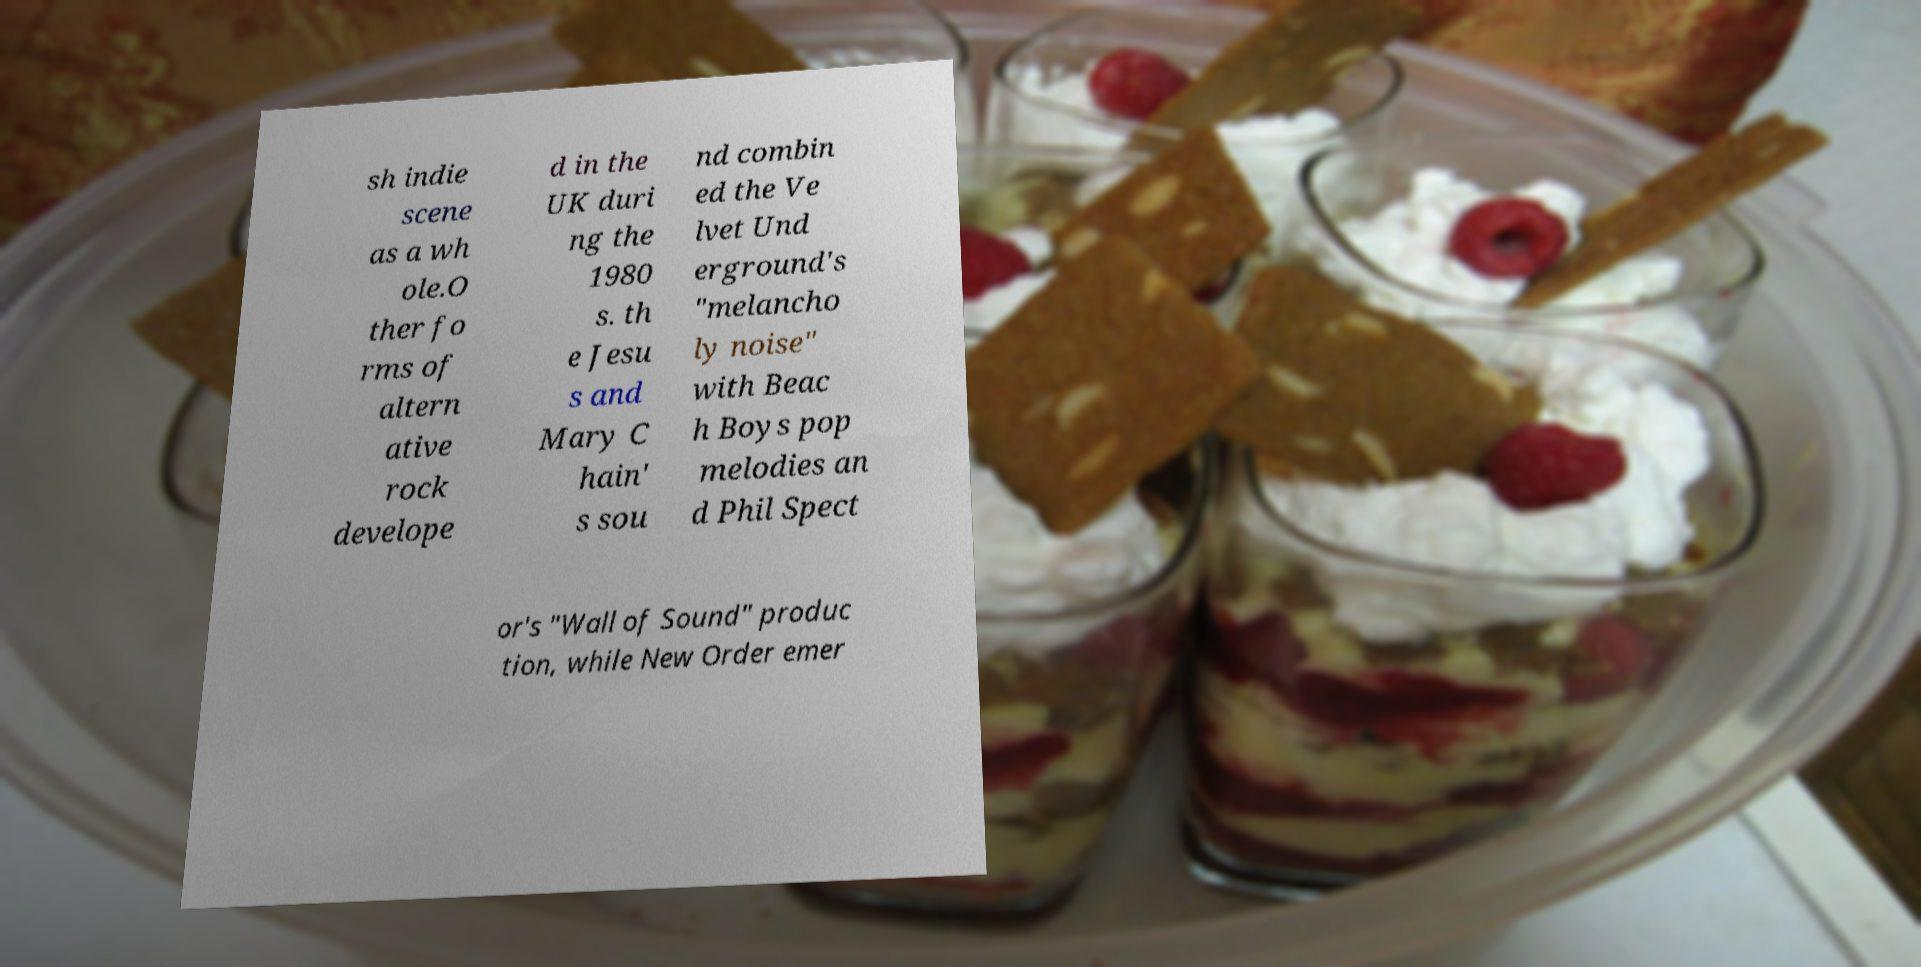What messages or text are displayed in this image? I need them in a readable, typed format. sh indie scene as a wh ole.O ther fo rms of altern ative rock develope d in the UK duri ng the 1980 s. th e Jesu s and Mary C hain' s sou nd combin ed the Ve lvet Und erground's "melancho ly noise" with Beac h Boys pop melodies an d Phil Spect or's "Wall of Sound" produc tion, while New Order emer 